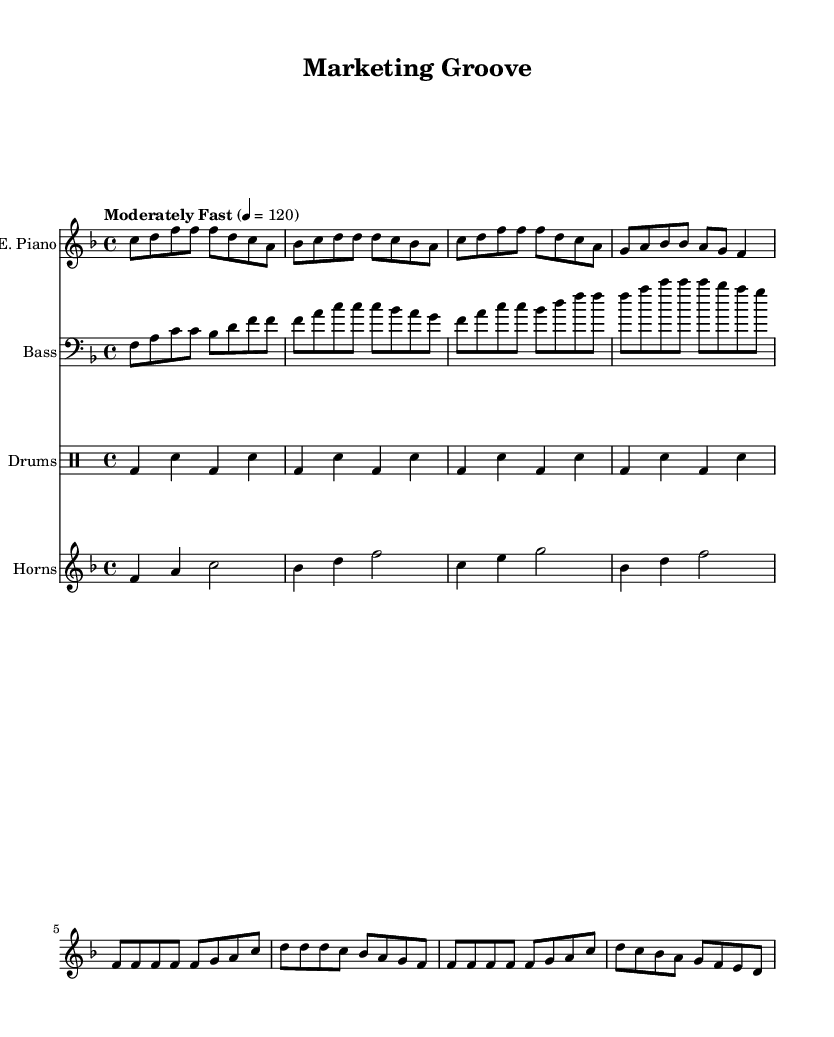What is the key signature of this music? The key signature is indicated at the beginning of the staff. The presence of one flat (B flat) indicates that the key is F major.
Answer: F major What is the time signature of this music? The time signature is shown as a fraction at the beginning of the staff. The top number (4) indicates there are four beats per measure, and the bottom number (4) denotes that a quarter note gets one beat.
Answer: 4/4 What is the tempo of this piece? The tempo marking at the beginning states "Moderately Fast" and indicates a metronome marking of 120 beats per minute, which guides the performer on how fast to play.
Answer: 120 How many measures are in the electric piano part? By counting the distinct sets of vertical lines separating the measures in the electric piano part, we find that there are eight measures.
Answer: 8 What type of instruments are used in this score? The instruments are labeled at the beginning of each staff. The score features electric piano, bass guitar, drums, and horns, indicating a rich blend typical in funky soul.
Answer: Electric piano, bass guitar, drums, horns Which rhythmic pattern is consistent throughout the drum part? Observing the drum part, the pattern features a kick drum on the first and third beats and a snare on the second and fourth beats, which is a standard backbeat commonly found in soul music.
Answer: Kick-snap pattern 